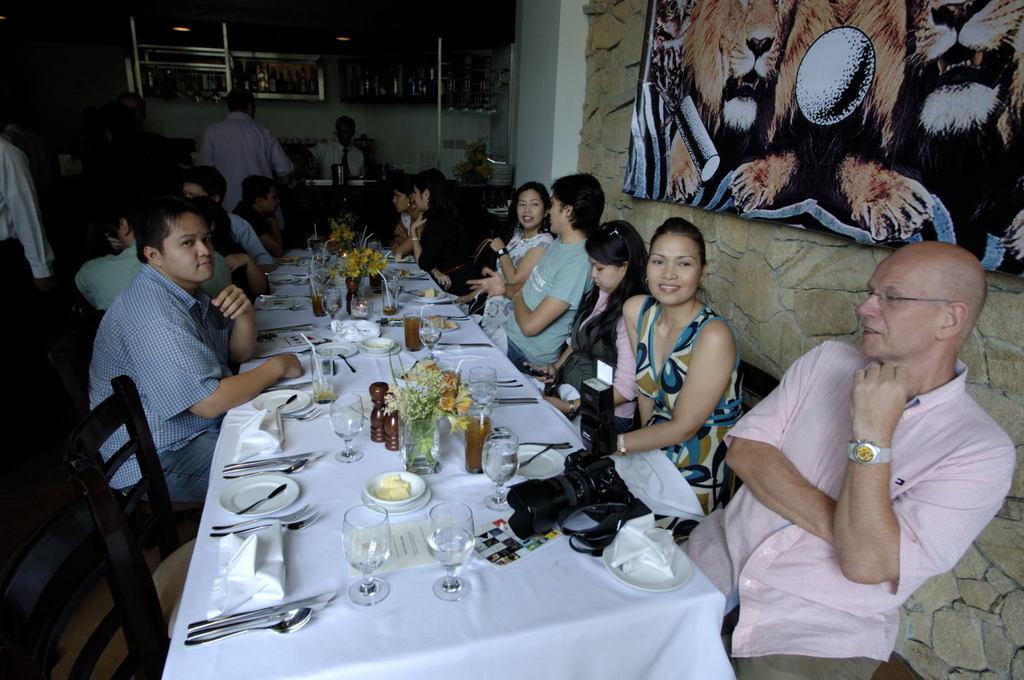How would you summarize this image in a sentence or two? people are seated around the table. on the table there is camera, glasses, spoon, knife, cloth , plate. behind them at the right there is a wall and a photo frame. 